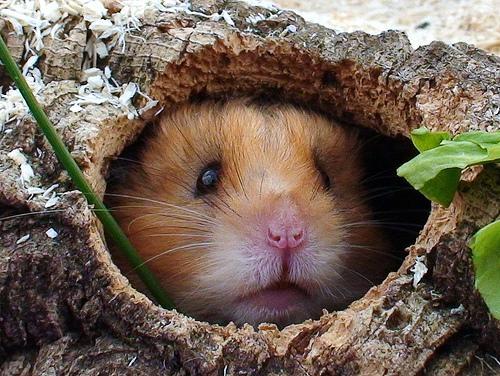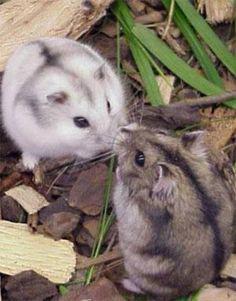The first image is the image on the left, the second image is the image on the right. Evaluate the accuracy of this statement regarding the images: "A rodent's face is seen through a hole in one image.". Is it true? Answer yes or no. Yes. The first image is the image on the left, the second image is the image on the right. Examine the images to the left and right. Is the description "More than five rodents are positioned in the woodchips and mulch." accurate? Answer yes or no. No. 